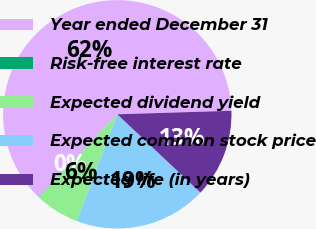Convert chart to OTSL. <chart><loc_0><loc_0><loc_500><loc_500><pie_chart><fcel>Year ended December 31<fcel>Risk-free interest rate<fcel>Expected dividend yield<fcel>Expected common stock price<fcel>Expected life (in years)<nl><fcel>62.42%<fcel>0.04%<fcel>6.28%<fcel>18.75%<fcel>12.51%<nl></chart> 